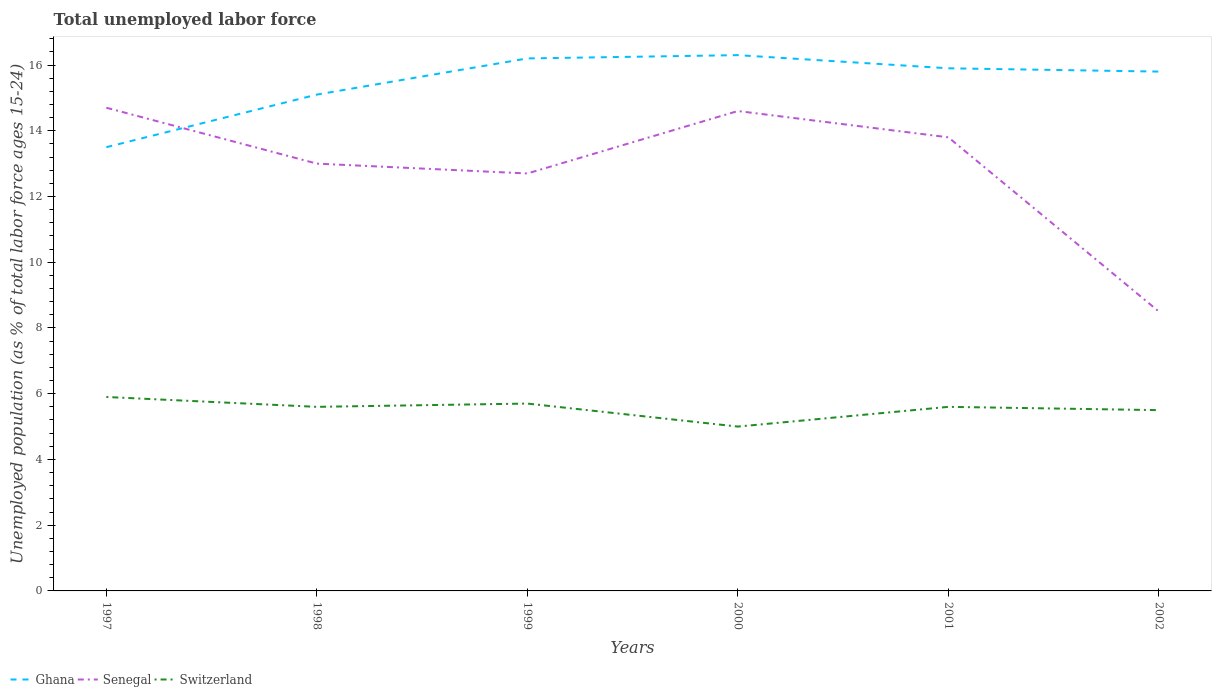In which year was the percentage of unemployed population in in Switzerland maximum?
Give a very brief answer. 2000. What is the total percentage of unemployed population in in Ghana in the graph?
Your response must be concise. -1.6. What is the difference between the highest and the second highest percentage of unemployed population in in Ghana?
Your response must be concise. 2.8. Is the percentage of unemployed population in in Switzerland strictly greater than the percentage of unemployed population in in Senegal over the years?
Make the answer very short. Yes. Are the values on the major ticks of Y-axis written in scientific E-notation?
Provide a short and direct response. No. Does the graph contain grids?
Keep it short and to the point. No. What is the title of the graph?
Offer a terse response. Total unemployed labor force. Does "Serbia" appear as one of the legend labels in the graph?
Your response must be concise. No. What is the label or title of the X-axis?
Your answer should be very brief. Years. What is the label or title of the Y-axis?
Provide a short and direct response. Unemployed population (as % of total labor force ages 15-24). What is the Unemployed population (as % of total labor force ages 15-24) in Ghana in 1997?
Make the answer very short. 13.5. What is the Unemployed population (as % of total labor force ages 15-24) of Senegal in 1997?
Keep it short and to the point. 14.7. What is the Unemployed population (as % of total labor force ages 15-24) in Switzerland in 1997?
Provide a short and direct response. 5.9. What is the Unemployed population (as % of total labor force ages 15-24) of Ghana in 1998?
Offer a very short reply. 15.1. What is the Unemployed population (as % of total labor force ages 15-24) in Switzerland in 1998?
Your response must be concise. 5.6. What is the Unemployed population (as % of total labor force ages 15-24) of Ghana in 1999?
Offer a terse response. 16.2. What is the Unemployed population (as % of total labor force ages 15-24) of Senegal in 1999?
Keep it short and to the point. 12.7. What is the Unemployed population (as % of total labor force ages 15-24) of Switzerland in 1999?
Your answer should be compact. 5.7. What is the Unemployed population (as % of total labor force ages 15-24) in Ghana in 2000?
Ensure brevity in your answer.  16.3. What is the Unemployed population (as % of total labor force ages 15-24) of Senegal in 2000?
Provide a succinct answer. 14.6. What is the Unemployed population (as % of total labor force ages 15-24) in Ghana in 2001?
Your response must be concise. 15.9. What is the Unemployed population (as % of total labor force ages 15-24) in Senegal in 2001?
Your answer should be very brief. 13.8. What is the Unemployed population (as % of total labor force ages 15-24) in Switzerland in 2001?
Ensure brevity in your answer.  5.6. What is the Unemployed population (as % of total labor force ages 15-24) in Ghana in 2002?
Your answer should be very brief. 15.8. What is the Unemployed population (as % of total labor force ages 15-24) in Switzerland in 2002?
Ensure brevity in your answer.  5.5. Across all years, what is the maximum Unemployed population (as % of total labor force ages 15-24) in Ghana?
Make the answer very short. 16.3. Across all years, what is the maximum Unemployed population (as % of total labor force ages 15-24) in Senegal?
Your answer should be very brief. 14.7. Across all years, what is the maximum Unemployed population (as % of total labor force ages 15-24) in Switzerland?
Give a very brief answer. 5.9. Across all years, what is the minimum Unemployed population (as % of total labor force ages 15-24) in Ghana?
Give a very brief answer. 13.5. Across all years, what is the minimum Unemployed population (as % of total labor force ages 15-24) of Switzerland?
Give a very brief answer. 5. What is the total Unemployed population (as % of total labor force ages 15-24) in Ghana in the graph?
Your answer should be very brief. 92.8. What is the total Unemployed population (as % of total labor force ages 15-24) in Senegal in the graph?
Ensure brevity in your answer.  77.3. What is the total Unemployed population (as % of total labor force ages 15-24) in Switzerland in the graph?
Make the answer very short. 33.3. What is the difference between the Unemployed population (as % of total labor force ages 15-24) in Senegal in 1997 and that in 1999?
Give a very brief answer. 2. What is the difference between the Unemployed population (as % of total labor force ages 15-24) of Ghana in 1997 and that in 2000?
Make the answer very short. -2.8. What is the difference between the Unemployed population (as % of total labor force ages 15-24) of Switzerland in 1997 and that in 2001?
Provide a succinct answer. 0.3. What is the difference between the Unemployed population (as % of total labor force ages 15-24) of Ghana in 1998 and that in 1999?
Your answer should be compact. -1.1. What is the difference between the Unemployed population (as % of total labor force ages 15-24) in Senegal in 1998 and that in 2000?
Your answer should be very brief. -1.6. What is the difference between the Unemployed population (as % of total labor force ages 15-24) of Ghana in 1998 and that in 2001?
Make the answer very short. -0.8. What is the difference between the Unemployed population (as % of total labor force ages 15-24) of Senegal in 1998 and that in 2002?
Ensure brevity in your answer.  4.5. What is the difference between the Unemployed population (as % of total labor force ages 15-24) of Senegal in 1999 and that in 2000?
Offer a terse response. -1.9. What is the difference between the Unemployed population (as % of total labor force ages 15-24) in Ghana in 1999 and that in 2002?
Your response must be concise. 0.4. What is the difference between the Unemployed population (as % of total labor force ages 15-24) of Senegal in 1999 and that in 2002?
Keep it short and to the point. 4.2. What is the difference between the Unemployed population (as % of total labor force ages 15-24) in Ghana in 2000 and that in 2001?
Make the answer very short. 0.4. What is the difference between the Unemployed population (as % of total labor force ages 15-24) of Senegal in 2000 and that in 2002?
Your answer should be compact. 6.1. What is the difference between the Unemployed population (as % of total labor force ages 15-24) of Switzerland in 2000 and that in 2002?
Give a very brief answer. -0.5. What is the difference between the Unemployed population (as % of total labor force ages 15-24) in Ghana in 2001 and that in 2002?
Offer a terse response. 0.1. What is the difference between the Unemployed population (as % of total labor force ages 15-24) in Senegal in 2001 and that in 2002?
Give a very brief answer. 5.3. What is the difference between the Unemployed population (as % of total labor force ages 15-24) of Ghana in 1997 and the Unemployed population (as % of total labor force ages 15-24) of Switzerland in 1998?
Your answer should be compact. 7.9. What is the difference between the Unemployed population (as % of total labor force ages 15-24) in Senegal in 1997 and the Unemployed population (as % of total labor force ages 15-24) in Switzerland in 1998?
Give a very brief answer. 9.1. What is the difference between the Unemployed population (as % of total labor force ages 15-24) in Senegal in 1997 and the Unemployed population (as % of total labor force ages 15-24) in Switzerland in 1999?
Provide a succinct answer. 9. What is the difference between the Unemployed population (as % of total labor force ages 15-24) in Ghana in 1997 and the Unemployed population (as % of total labor force ages 15-24) in Senegal in 2000?
Keep it short and to the point. -1.1. What is the difference between the Unemployed population (as % of total labor force ages 15-24) of Ghana in 1997 and the Unemployed population (as % of total labor force ages 15-24) of Switzerland in 2000?
Offer a very short reply. 8.5. What is the difference between the Unemployed population (as % of total labor force ages 15-24) of Senegal in 1997 and the Unemployed population (as % of total labor force ages 15-24) of Switzerland in 2000?
Your answer should be very brief. 9.7. What is the difference between the Unemployed population (as % of total labor force ages 15-24) in Ghana in 1997 and the Unemployed population (as % of total labor force ages 15-24) in Switzerland in 2001?
Your response must be concise. 7.9. What is the difference between the Unemployed population (as % of total labor force ages 15-24) in Ghana in 1998 and the Unemployed population (as % of total labor force ages 15-24) in Senegal in 1999?
Provide a short and direct response. 2.4. What is the difference between the Unemployed population (as % of total labor force ages 15-24) of Senegal in 1998 and the Unemployed population (as % of total labor force ages 15-24) of Switzerland in 1999?
Offer a very short reply. 7.3. What is the difference between the Unemployed population (as % of total labor force ages 15-24) of Ghana in 1998 and the Unemployed population (as % of total labor force ages 15-24) of Switzerland in 2000?
Your answer should be very brief. 10.1. What is the difference between the Unemployed population (as % of total labor force ages 15-24) in Ghana in 1998 and the Unemployed population (as % of total labor force ages 15-24) in Switzerland in 2001?
Keep it short and to the point. 9.5. What is the difference between the Unemployed population (as % of total labor force ages 15-24) in Senegal in 1998 and the Unemployed population (as % of total labor force ages 15-24) in Switzerland in 2001?
Keep it short and to the point. 7.4. What is the difference between the Unemployed population (as % of total labor force ages 15-24) in Ghana in 1998 and the Unemployed population (as % of total labor force ages 15-24) in Senegal in 2002?
Provide a short and direct response. 6.6. What is the difference between the Unemployed population (as % of total labor force ages 15-24) in Ghana in 1998 and the Unemployed population (as % of total labor force ages 15-24) in Switzerland in 2002?
Offer a very short reply. 9.6. What is the difference between the Unemployed population (as % of total labor force ages 15-24) in Ghana in 1999 and the Unemployed population (as % of total labor force ages 15-24) in Switzerland in 2000?
Provide a short and direct response. 11.2. What is the difference between the Unemployed population (as % of total labor force ages 15-24) of Ghana in 1999 and the Unemployed population (as % of total labor force ages 15-24) of Senegal in 2002?
Provide a succinct answer. 7.7. What is the difference between the Unemployed population (as % of total labor force ages 15-24) of Ghana in 1999 and the Unemployed population (as % of total labor force ages 15-24) of Switzerland in 2002?
Give a very brief answer. 10.7. What is the difference between the Unemployed population (as % of total labor force ages 15-24) in Senegal in 1999 and the Unemployed population (as % of total labor force ages 15-24) in Switzerland in 2002?
Give a very brief answer. 7.2. What is the difference between the Unemployed population (as % of total labor force ages 15-24) in Ghana in 2000 and the Unemployed population (as % of total labor force ages 15-24) in Switzerland in 2001?
Offer a terse response. 10.7. What is the difference between the Unemployed population (as % of total labor force ages 15-24) of Senegal in 2000 and the Unemployed population (as % of total labor force ages 15-24) of Switzerland in 2001?
Your answer should be very brief. 9. What is the difference between the Unemployed population (as % of total labor force ages 15-24) of Ghana in 2000 and the Unemployed population (as % of total labor force ages 15-24) of Switzerland in 2002?
Offer a very short reply. 10.8. What is the difference between the Unemployed population (as % of total labor force ages 15-24) of Ghana in 2001 and the Unemployed population (as % of total labor force ages 15-24) of Senegal in 2002?
Ensure brevity in your answer.  7.4. What is the difference between the Unemployed population (as % of total labor force ages 15-24) in Ghana in 2001 and the Unemployed population (as % of total labor force ages 15-24) in Switzerland in 2002?
Offer a terse response. 10.4. What is the difference between the Unemployed population (as % of total labor force ages 15-24) of Senegal in 2001 and the Unemployed population (as % of total labor force ages 15-24) of Switzerland in 2002?
Make the answer very short. 8.3. What is the average Unemployed population (as % of total labor force ages 15-24) in Ghana per year?
Make the answer very short. 15.47. What is the average Unemployed population (as % of total labor force ages 15-24) in Senegal per year?
Make the answer very short. 12.88. What is the average Unemployed population (as % of total labor force ages 15-24) in Switzerland per year?
Provide a short and direct response. 5.55. In the year 1997, what is the difference between the Unemployed population (as % of total labor force ages 15-24) of Senegal and Unemployed population (as % of total labor force ages 15-24) of Switzerland?
Keep it short and to the point. 8.8. In the year 1998, what is the difference between the Unemployed population (as % of total labor force ages 15-24) in Ghana and Unemployed population (as % of total labor force ages 15-24) in Senegal?
Make the answer very short. 2.1. In the year 1998, what is the difference between the Unemployed population (as % of total labor force ages 15-24) of Ghana and Unemployed population (as % of total labor force ages 15-24) of Switzerland?
Your answer should be compact. 9.5. In the year 1998, what is the difference between the Unemployed population (as % of total labor force ages 15-24) in Senegal and Unemployed population (as % of total labor force ages 15-24) in Switzerland?
Keep it short and to the point. 7.4. In the year 1999, what is the difference between the Unemployed population (as % of total labor force ages 15-24) in Ghana and Unemployed population (as % of total labor force ages 15-24) in Senegal?
Provide a succinct answer. 3.5. In the year 1999, what is the difference between the Unemployed population (as % of total labor force ages 15-24) in Ghana and Unemployed population (as % of total labor force ages 15-24) in Switzerland?
Give a very brief answer. 10.5. In the year 1999, what is the difference between the Unemployed population (as % of total labor force ages 15-24) in Senegal and Unemployed population (as % of total labor force ages 15-24) in Switzerland?
Offer a very short reply. 7. In the year 2000, what is the difference between the Unemployed population (as % of total labor force ages 15-24) of Ghana and Unemployed population (as % of total labor force ages 15-24) of Switzerland?
Offer a very short reply. 11.3. In the year 2001, what is the difference between the Unemployed population (as % of total labor force ages 15-24) in Ghana and Unemployed population (as % of total labor force ages 15-24) in Senegal?
Ensure brevity in your answer.  2.1. In the year 2002, what is the difference between the Unemployed population (as % of total labor force ages 15-24) in Ghana and Unemployed population (as % of total labor force ages 15-24) in Switzerland?
Offer a terse response. 10.3. What is the ratio of the Unemployed population (as % of total labor force ages 15-24) of Ghana in 1997 to that in 1998?
Provide a short and direct response. 0.89. What is the ratio of the Unemployed population (as % of total labor force ages 15-24) in Senegal in 1997 to that in 1998?
Make the answer very short. 1.13. What is the ratio of the Unemployed population (as % of total labor force ages 15-24) of Switzerland in 1997 to that in 1998?
Your answer should be compact. 1.05. What is the ratio of the Unemployed population (as % of total labor force ages 15-24) of Ghana in 1997 to that in 1999?
Provide a succinct answer. 0.83. What is the ratio of the Unemployed population (as % of total labor force ages 15-24) in Senegal in 1997 to that in 1999?
Your answer should be very brief. 1.16. What is the ratio of the Unemployed population (as % of total labor force ages 15-24) of Switzerland in 1997 to that in 1999?
Provide a short and direct response. 1.04. What is the ratio of the Unemployed population (as % of total labor force ages 15-24) of Ghana in 1997 to that in 2000?
Keep it short and to the point. 0.83. What is the ratio of the Unemployed population (as % of total labor force ages 15-24) of Senegal in 1997 to that in 2000?
Provide a short and direct response. 1.01. What is the ratio of the Unemployed population (as % of total labor force ages 15-24) of Switzerland in 1997 to that in 2000?
Your answer should be compact. 1.18. What is the ratio of the Unemployed population (as % of total labor force ages 15-24) in Ghana in 1997 to that in 2001?
Give a very brief answer. 0.85. What is the ratio of the Unemployed population (as % of total labor force ages 15-24) of Senegal in 1997 to that in 2001?
Provide a succinct answer. 1.07. What is the ratio of the Unemployed population (as % of total labor force ages 15-24) of Switzerland in 1997 to that in 2001?
Make the answer very short. 1.05. What is the ratio of the Unemployed population (as % of total labor force ages 15-24) of Ghana in 1997 to that in 2002?
Give a very brief answer. 0.85. What is the ratio of the Unemployed population (as % of total labor force ages 15-24) of Senegal in 1997 to that in 2002?
Keep it short and to the point. 1.73. What is the ratio of the Unemployed population (as % of total labor force ages 15-24) in Switzerland in 1997 to that in 2002?
Make the answer very short. 1.07. What is the ratio of the Unemployed population (as % of total labor force ages 15-24) of Ghana in 1998 to that in 1999?
Your response must be concise. 0.93. What is the ratio of the Unemployed population (as % of total labor force ages 15-24) of Senegal in 1998 to that in 1999?
Keep it short and to the point. 1.02. What is the ratio of the Unemployed population (as % of total labor force ages 15-24) of Switzerland in 1998 to that in 1999?
Provide a short and direct response. 0.98. What is the ratio of the Unemployed population (as % of total labor force ages 15-24) of Ghana in 1998 to that in 2000?
Your response must be concise. 0.93. What is the ratio of the Unemployed population (as % of total labor force ages 15-24) of Senegal in 1998 to that in 2000?
Offer a terse response. 0.89. What is the ratio of the Unemployed population (as % of total labor force ages 15-24) in Switzerland in 1998 to that in 2000?
Keep it short and to the point. 1.12. What is the ratio of the Unemployed population (as % of total labor force ages 15-24) of Ghana in 1998 to that in 2001?
Offer a terse response. 0.95. What is the ratio of the Unemployed population (as % of total labor force ages 15-24) of Senegal in 1998 to that in 2001?
Give a very brief answer. 0.94. What is the ratio of the Unemployed population (as % of total labor force ages 15-24) of Switzerland in 1998 to that in 2001?
Offer a terse response. 1. What is the ratio of the Unemployed population (as % of total labor force ages 15-24) of Ghana in 1998 to that in 2002?
Give a very brief answer. 0.96. What is the ratio of the Unemployed population (as % of total labor force ages 15-24) in Senegal in 1998 to that in 2002?
Ensure brevity in your answer.  1.53. What is the ratio of the Unemployed population (as % of total labor force ages 15-24) of Switzerland in 1998 to that in 2002?
Your response must be concise. 1.02. What is the ratio of the Unemployed population (as % of total labor force ages 15-24) in Ghana in 1999 to that in 2000?
Your response must be concise. 0.99. What is the ratio of the Unemployed population (as % of total labor force ages 15-24) of Senegal in 1999 to that in 2000?
Make the answer very short. 0.87. What is the ratio of the Unemployed population (as % of total labor force ages 15-24) of Switzerland in 1999 to that in 2000?
Provide a succinct answer. 1.14. What is the ratio of the Unemployed population (as % of total labor force ages 15-24) of Ghana in 1999 to that in 2001?
Provide a short and direct response. 1.02. What is the ratio of the Unemployed population (as % of total labor force ages 15-24) of Senegal in 1999 to that in 2001?
Provide a short and direct response. 0.92. What is the ratio of the Unemployed population (as % of total labor force ages 15-24) of Switzerland in 1999 to that in 2001?
Provide a short and direct response. 1.02. What is the ratio of the Unemployed population (as % of total labor force ages 15-24) of Ghana in 1999 to that in 2002?
Offer a terse response. 1.03. What is the ratio of the Unemployed population (as % of total labor force ages 15-24) in Senegal in 1999 to that in 2002?
Your answer should be compact. 1.49. What is the ratio of the Unemployed population (as % of total labor force ages 15-24) of Switzerland in 1999 to that in 2002?
Ensure brevity in your answer.  1.04. What is the ratio of the Unemployed population (as % of total labor force ages 15-24) of Ghana in 2000 to that in 2001?
Ensure brevity in your answer.  1.03. What is the ratio of the Unemployed population (as % of total labor force ages 15-24) of Senegal in 2000 to that in 2001?
Ensure brevity in your answer.  1.06. What is the ratio of the Unemployed population (as % of total labor force ages 15-24) of Switzerland in 2000 to that in 2001?
Ensure brevity in your answer.  0.89. What is the ratio of the Unemployed population (as % of total labor force ages 15-24) of Ghana in 2000 to that in 2002?
Your answer should be compact. 1.03. What is the ratio of the Unemployed population (as % of total labor force ages 15-24) of Senegal in 2000 to that in 2002?
Offer a terse response. 1.72. What is the ratio of the Unemployed population (as % of total labor force ages 15-24) of Switzerland in 2000 to that in 2002?
Offer a very short reply. 0.91. What is the ratio of the Unemployed population (as % of total labor force ages 15-24) of Senegal in 2001 to that in 2002?
Give a very brief answer. 1.62. What is the ratio of the Unemployed population (as % of total labor force ages 15-24) in Switzerland in 2001 to that in 2002?
Offer a very short reply. 1.02. What is the difference between the highest and the second highest Unemployed population (as % of total labor force ages 15-24) of Ghana?
Your response must be concise. 0.1. What is the difference between the highest and the lowest Unemployed population (as % of total labor force ages 15-24) in Ghana?
Provide a short and direct response. 2.8. What is the difference between the highest and the lowest Unemployed population (as % of total labor force ages 15-24) of Switzerland?
Provide a short and direct response. 0.9. 